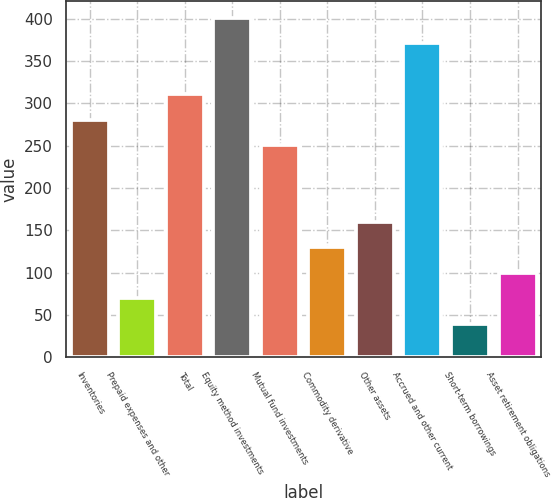Convert chart to OTSL. <chart><loc_0><loc_0><loc_500><loc_500><bar_chart><fcel>Inventories<fcel>Prepaid expenses and other<fcel>Total<fcel>Equity method investments<fcel>Mutual fund investments<fcel>Commodity derivative<fcel>Other assets<fcel>Accrued and other current<fcel>Short-term borrowings<fcel>Asset retirement obligations<nl><fcel>280.8<fcel>69.4<fcel>311<fcel>401.6<fcel>250.6<fcel>129.8<fcel>160<fcel>371.4<fcel>39.2<fcel>99.6<nl></chart> 